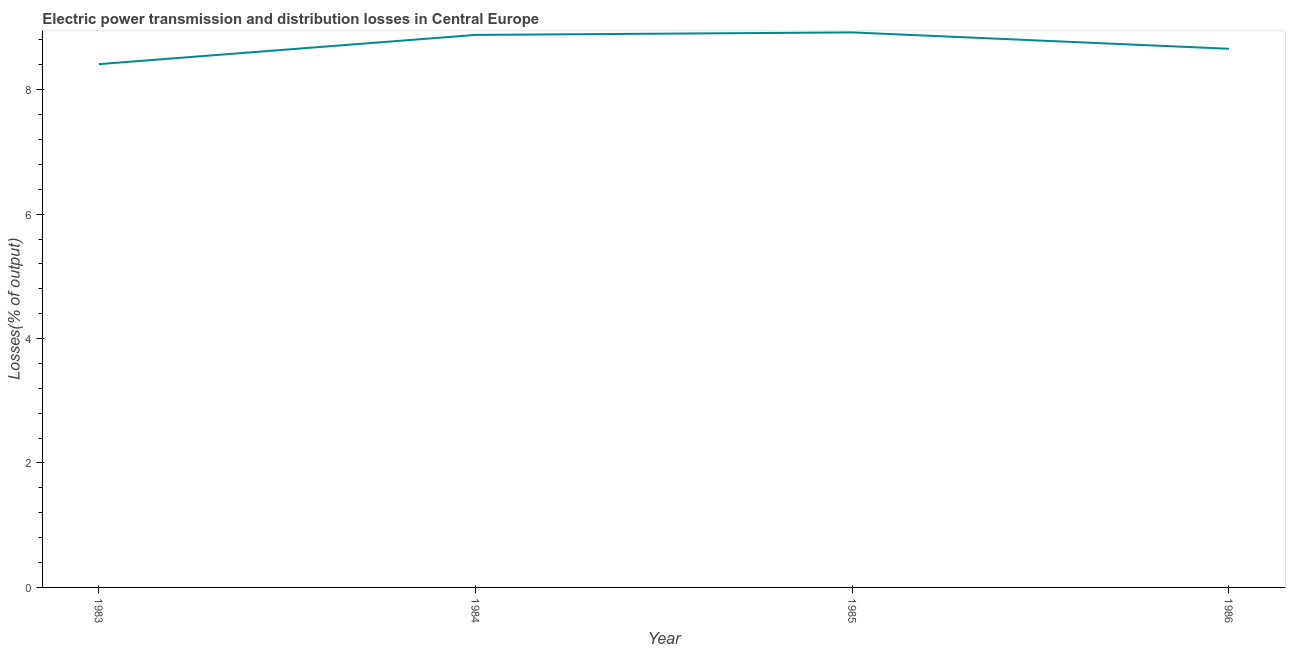What is the electric power transmission and distribution losses in 1985?
Your answer should be compact. 8.92. Across all years, what is the maximum electric power transmission and distribution losses?
Provide a succinct answer. 8.92. Across all years, what is the minimum electric power transmission and distribution losses?
Provide a succinct answer. 8.41. In which year was the electric power transmission and distribution losses maximum?
Give a very brief answer. 1985. What is the sum of the electric power transmission and distribution losses?
Make the answer very short. 34.87. What is the difference between the electric power transmission and distribution losses in 1983 and 1985?
Provide a short and direct response. -0.51. What is the average electric power transmission and distribution losses per year?
Ensure brevity in your answer.  8.72. What is the median electric power transmission and distribution losses?
Make the answer very short. 8.77. In how many years, is the electric power transmission and distribution losses greater than 7.2 %?
Provide a succinct answer. 4. What is the ratio of the electric power transmission and distribution losses in 1983 to that in 1985?
Ensure brevity in your answer.  0.94. What is the difference between the highest and the second highest electric power transmission and distribution losses?
Make the answer very short. 0.04. Is the sum of the electric power transmission and distribution losses in 1984 and 1985 greater than the maximum electric power transmission and distribution losses across all years?
Ensure brevity in your answer.  Yes. What is the difference between the highest and the lowest electric power transmission and distribution losses?
Offer a very short reply. 0.51. Does the electric power transmission and distribution losses monotonically increase over the years?
Offer a very short reply. No. How many lines are there?
Make the answer very short. 1. How many years are there in the graph?
Give a very brief answer. 4. What is the difference between two consecutive major ticks on the Y-axis?
Offer a very short reply. 2. Are the values on the major ticks of Y-axis written in scientific E-notation?
Keep it short and to the point. No. Does the graph contain grids?
Your response must be concise. No. What is the title of the graph?
Provide a short and direct response. Electric power transmission and distribution losses in Central Europe. What is the label or title of the Y-axis?
Offer a terse response. Losses(% of output). What is the Losses(% of output) of 1983?
Your response must be concise. 8.41. What is the Losses(% of output) of 1984?
Offer a very short reply. 8.88. What is the Losses(% of output) in 1985?
Your answer should be compact. 8.92. What is the Losses(% of output) of 1986?
Give a very brief answer. 8.66. What is the difference between the Losses(% of output) in 1983 and 1984?
Make the answer very short. -0.47. What is the difference between the Losses(% of output) in 1983 and 1985?
Your answer should be compact. -0.51. What is the difference between the Losses(% of output) in 1983 and 1986?
Offer a very short reply. -0.25. What is the difference between the Losses(% of output) in 1984 and 1985?
Offer a terse response. -0.04. What is the difference between the Losses(% of output) in 1984 and 1986?
Give a very brief answer. 0.22. What is the difference between the Losses(% of output) in 1985 and 1986?
Offer a terse response. 0.26. What is the ratio of the Losses(% of output) in 1983 to that in 1984?
Provide a short and direct response. 0.95. What is the ratio of the Losses(% of output) in 1983 to that in 1985?
Give a very brief answer. 0.94. What is the ratio of the Losses(% of output) in 1983 to that in 1986?
Your answer should be very brief. 0.97. 